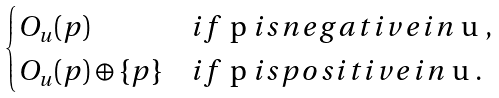Convert formula to latex. <formula><loc_0><loc_0><loc_500><loc_500>\begin{cases} O _ { u } ( p ) & i f $ p $ i s n e g a t i v e i n $ u $ , \\ O _ { u } ( p ) \oplus \{ p \} & i f $ p $ i s p o s i t i v e i n $ u $ . \end{cases}</formula> 